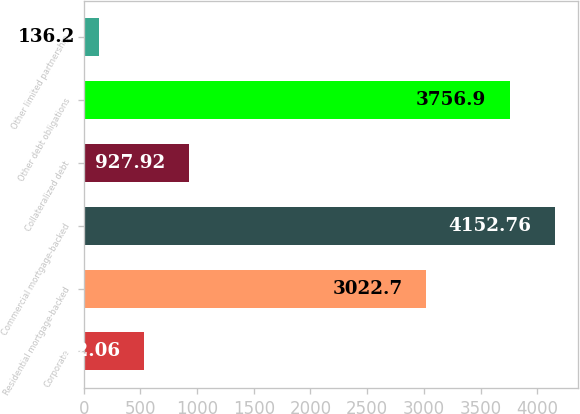Convert chart. <chart><loc_0><loc_0><loc_500><loc_500><bar_chart><fcel>Corporate<fcel>Residential mortgage-backed<fcel>Commercial mortgage-backed<fcel>Collateralized debt<fcel>Other debt obligations<fcel>Other limited partnership<nl><fcel>532.06<fcel>3022.7<fcel>4152.76<fcel>927.92<fcel>3756.9<fcel>136.2<nl></chart> 